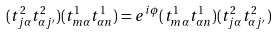<formula> <loc_0><loc_0><loc_500><loc_500>( t ^ { 2 } _ { j \alpha } t ^ { 2 } _ { \alpha j ^ { \prime } } ) ( t ^ { 1 } _ { m \alpha } t ^ { 1 } _ { \alpha n } ) = e ^ { i \phi } ( t ^ { 1 } _ { m \alpha } t ^ { 1 } _ { \alpha n } ) ( t ^ { 2 } _ { j \alpha } t ^ { 2 } _ { \alpha j ^ { \prime } } )</formula> 